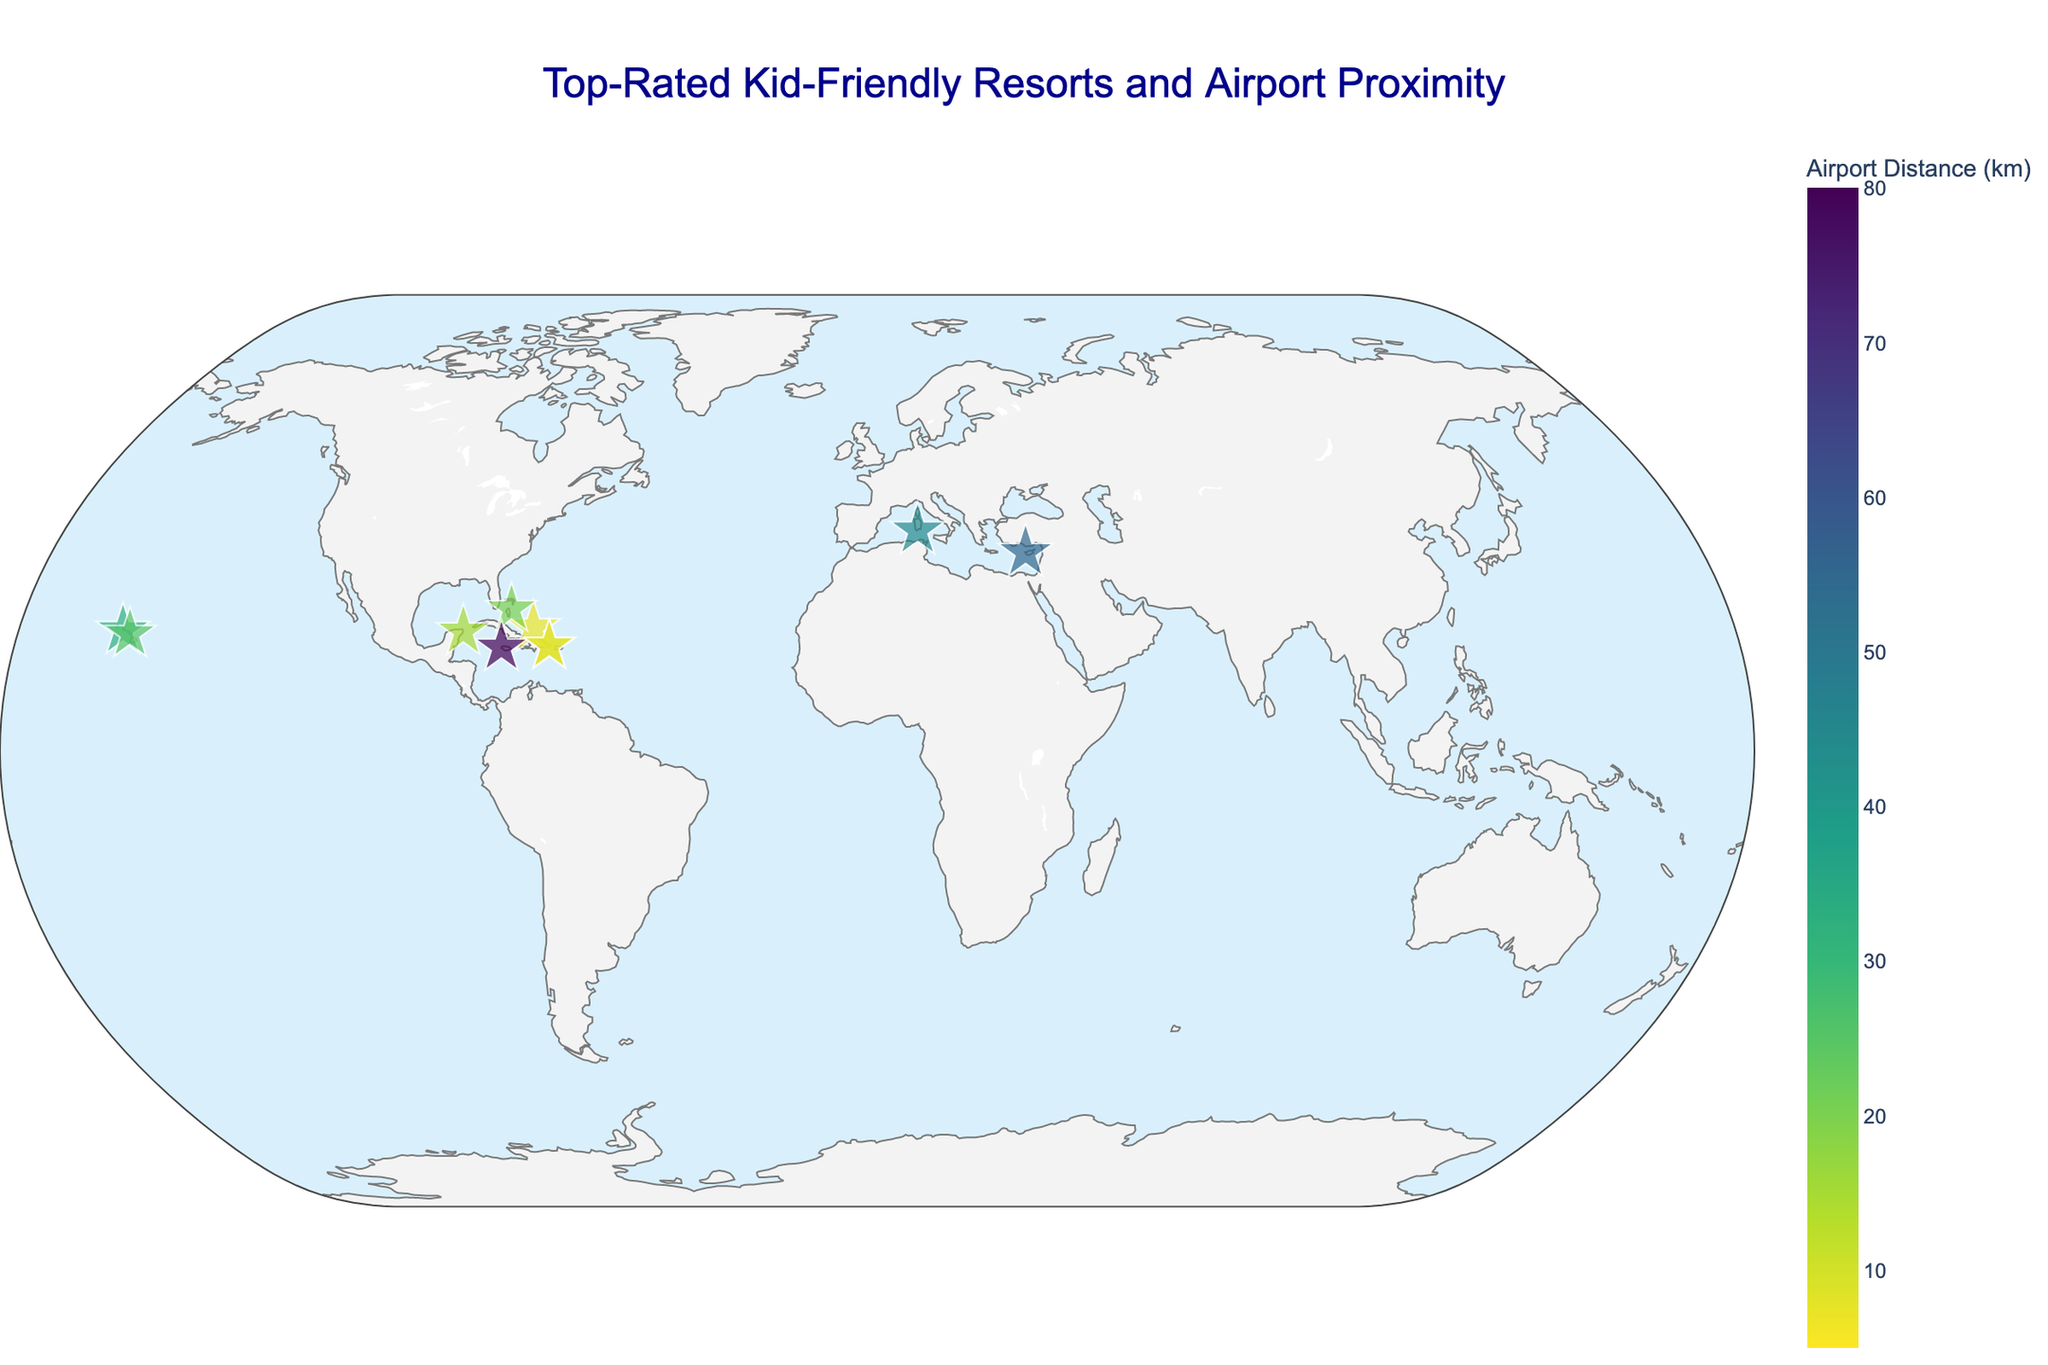How many resorts are shown on the map? There are 10 resorts listed in the data, and each resort is represented by a star marker on the map.
Answer: 10 What is the closest resort to an airport? According to the data, "Club Med Punta Cana" is only 5 km away from Punta Cana International Airport.
Answer: Club Med Punta Cana Which resort has the highest rating? The data shows that "Anassa Hotel" has the highest rating of 4.9, which can be identified by the larger size of the star marker on the map.
Answer: Anassa Hotel What is the average distance to the nearest airport for all resorts? The total distance to the nearest airport for all resorts is 7 + 5 + 32 + 20 + 25 + 80 + 9 + 45 + 15 + 55 = 293 km. Dividing this by the number of resorts (10) gives the average distance as 293 / 10 = 29.3 km.
Answer: 29.3 km Which resorts have a rating greater than 4.7? The data indicates that "Beaches Turks & Caicos" (4.8), "Forte Village Resort" (4.8), and "Anassa Hotel" (4.9) have ratings greater than 4.7.
Answer: Beaches Turks & Caicos, Forte Village Resort, Anassa Hotel Which resort is farthest from its nearest airport? The data shows that "Beaches Negril Resort & Spa" is located 80 km away from Sangster International Airport, making it the farthest resort from an airport.
Answer: Beaches Negril Resort & Spa What is the total number of resorts located in the Caribbean region? The data shows these resorts in the Caribbean region: "Beaches Turks & Caicos" (Providenciales, Turks and Caicos), "Atlantis Paradise Island" (Nassau, Bahamas), "Club Med Punta Cana" (Punta Cana, Dominican Republic), and "Nickelodeon Hotels & Resorts Punta Cana" (Punta Cana, Dominican Republic). This gives a total of 4 Caribbean resorts.
Answer: 4 Which resort is represented by the largest star marker on the map? Ratings determine marker size, and "Anassa Hotel," with the highest rating of 4.9, should have the largest star marker.
Answer: Anassa Hotel 